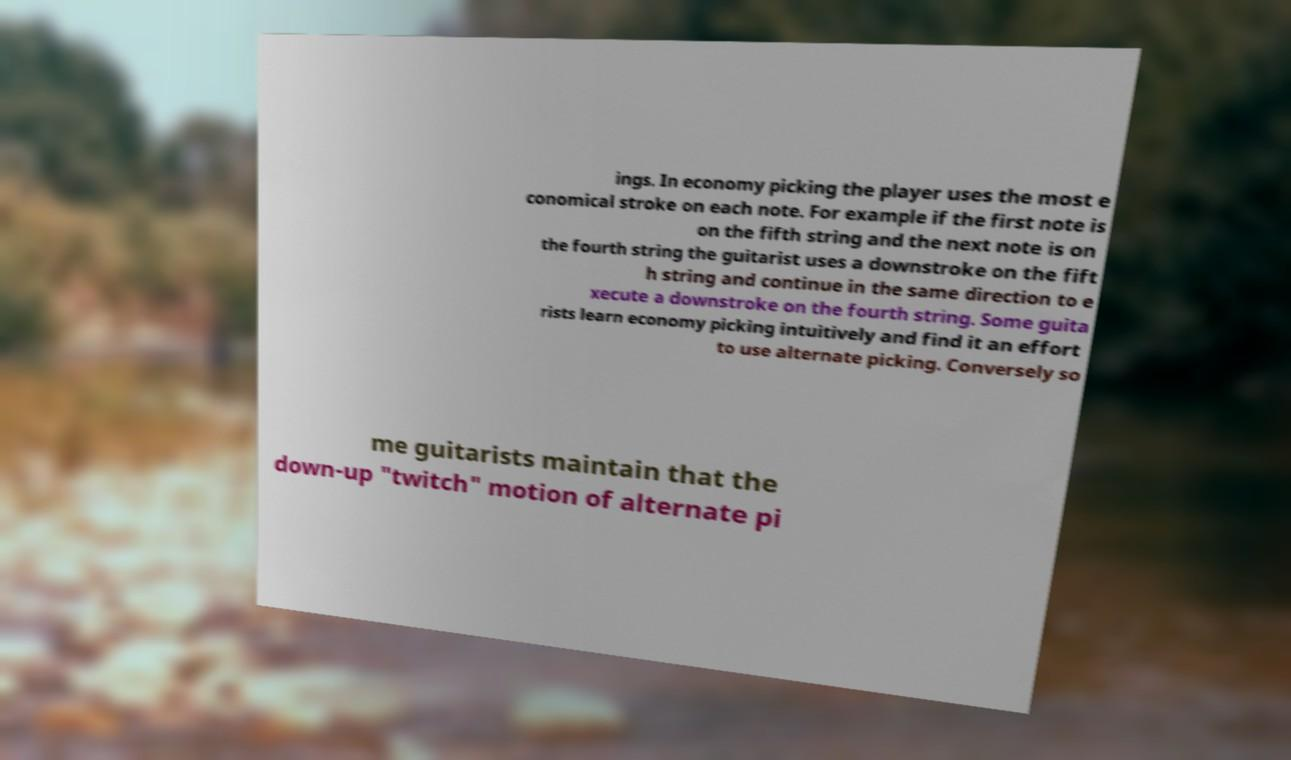There's text embedded in this image that I need extracted. Can you transcribe it verbatim? ings. In economy picking the player uses the most e conomical stroke on each note. For example if the first note is on the fifth string and the next note is on the fourth string the guitarist uses a downstroke on the fift h string and continue in the same direction to e xecute a downstroke on the fourth string. Some guita rists learn economy picking intuitively and find it an effort to use alternate picking. Conversely so me guitarists maintain that the down-up "twitch" motion of alternate pi 